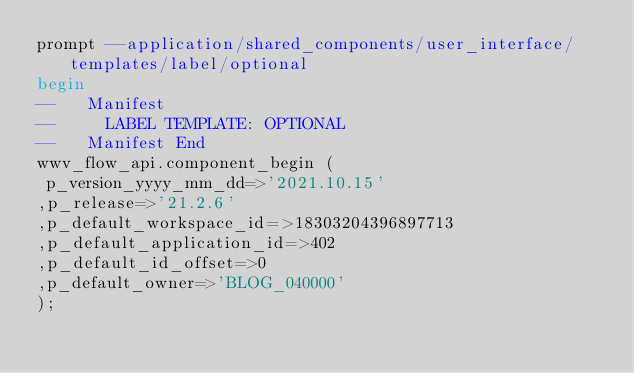Convert code to text. <code><loc_0><loc_0><loc_500><loc_500><_SQL_>prompt --application/shared_components/user_interface/templates/label/optional
begin
--   Manifest
--     LABEL TEMPLATE: OPTIONAL
--   Manifest End
wwv_flow_api.component_begin (
 p_version_yyyy_mm_dd=>'2021.10.15'
,p_release=>'21.2.6'
,p_default_workspace_id=>18303204396897713
,p_default_application_id=>402
,p_default_id_offset=>0
,p_default_owner=>'BLOG_040000'
);</code> 